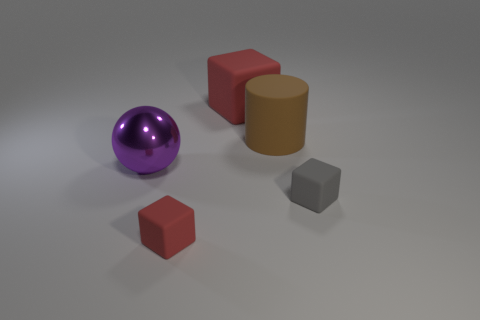Add 2 big cylinders. How many objects exist? 7 Subtract all blocks. How many objects are left? 2 Add 1 large purple metallic balls. How many large purple metallic balls are left? 2 Add 5 tiny rubber balls. How many tiny rubber balls exist? 5 Subtract 0 blue blocks. How many objects are left? 5 Subtract all purple shiny things. Subtract all cylinders. How many objects are left? 3 